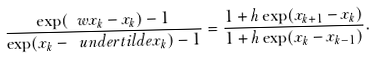<formula> <loc_0><loc_0><loc_500><loc_500>\frac { \exp ( \ w x _ { k } - x _ { k } ) - 1 } { \exp ( x _ { k } - \ u n d e r t i l d e { x _ { k } } ) - 1 } = \frac { 1 + h \exp ( x _ { k + 1 } - x _ { k } ) } { 1 + h \exp ( x _ { k } - x _ { k - 1 } ) } .</formula> 